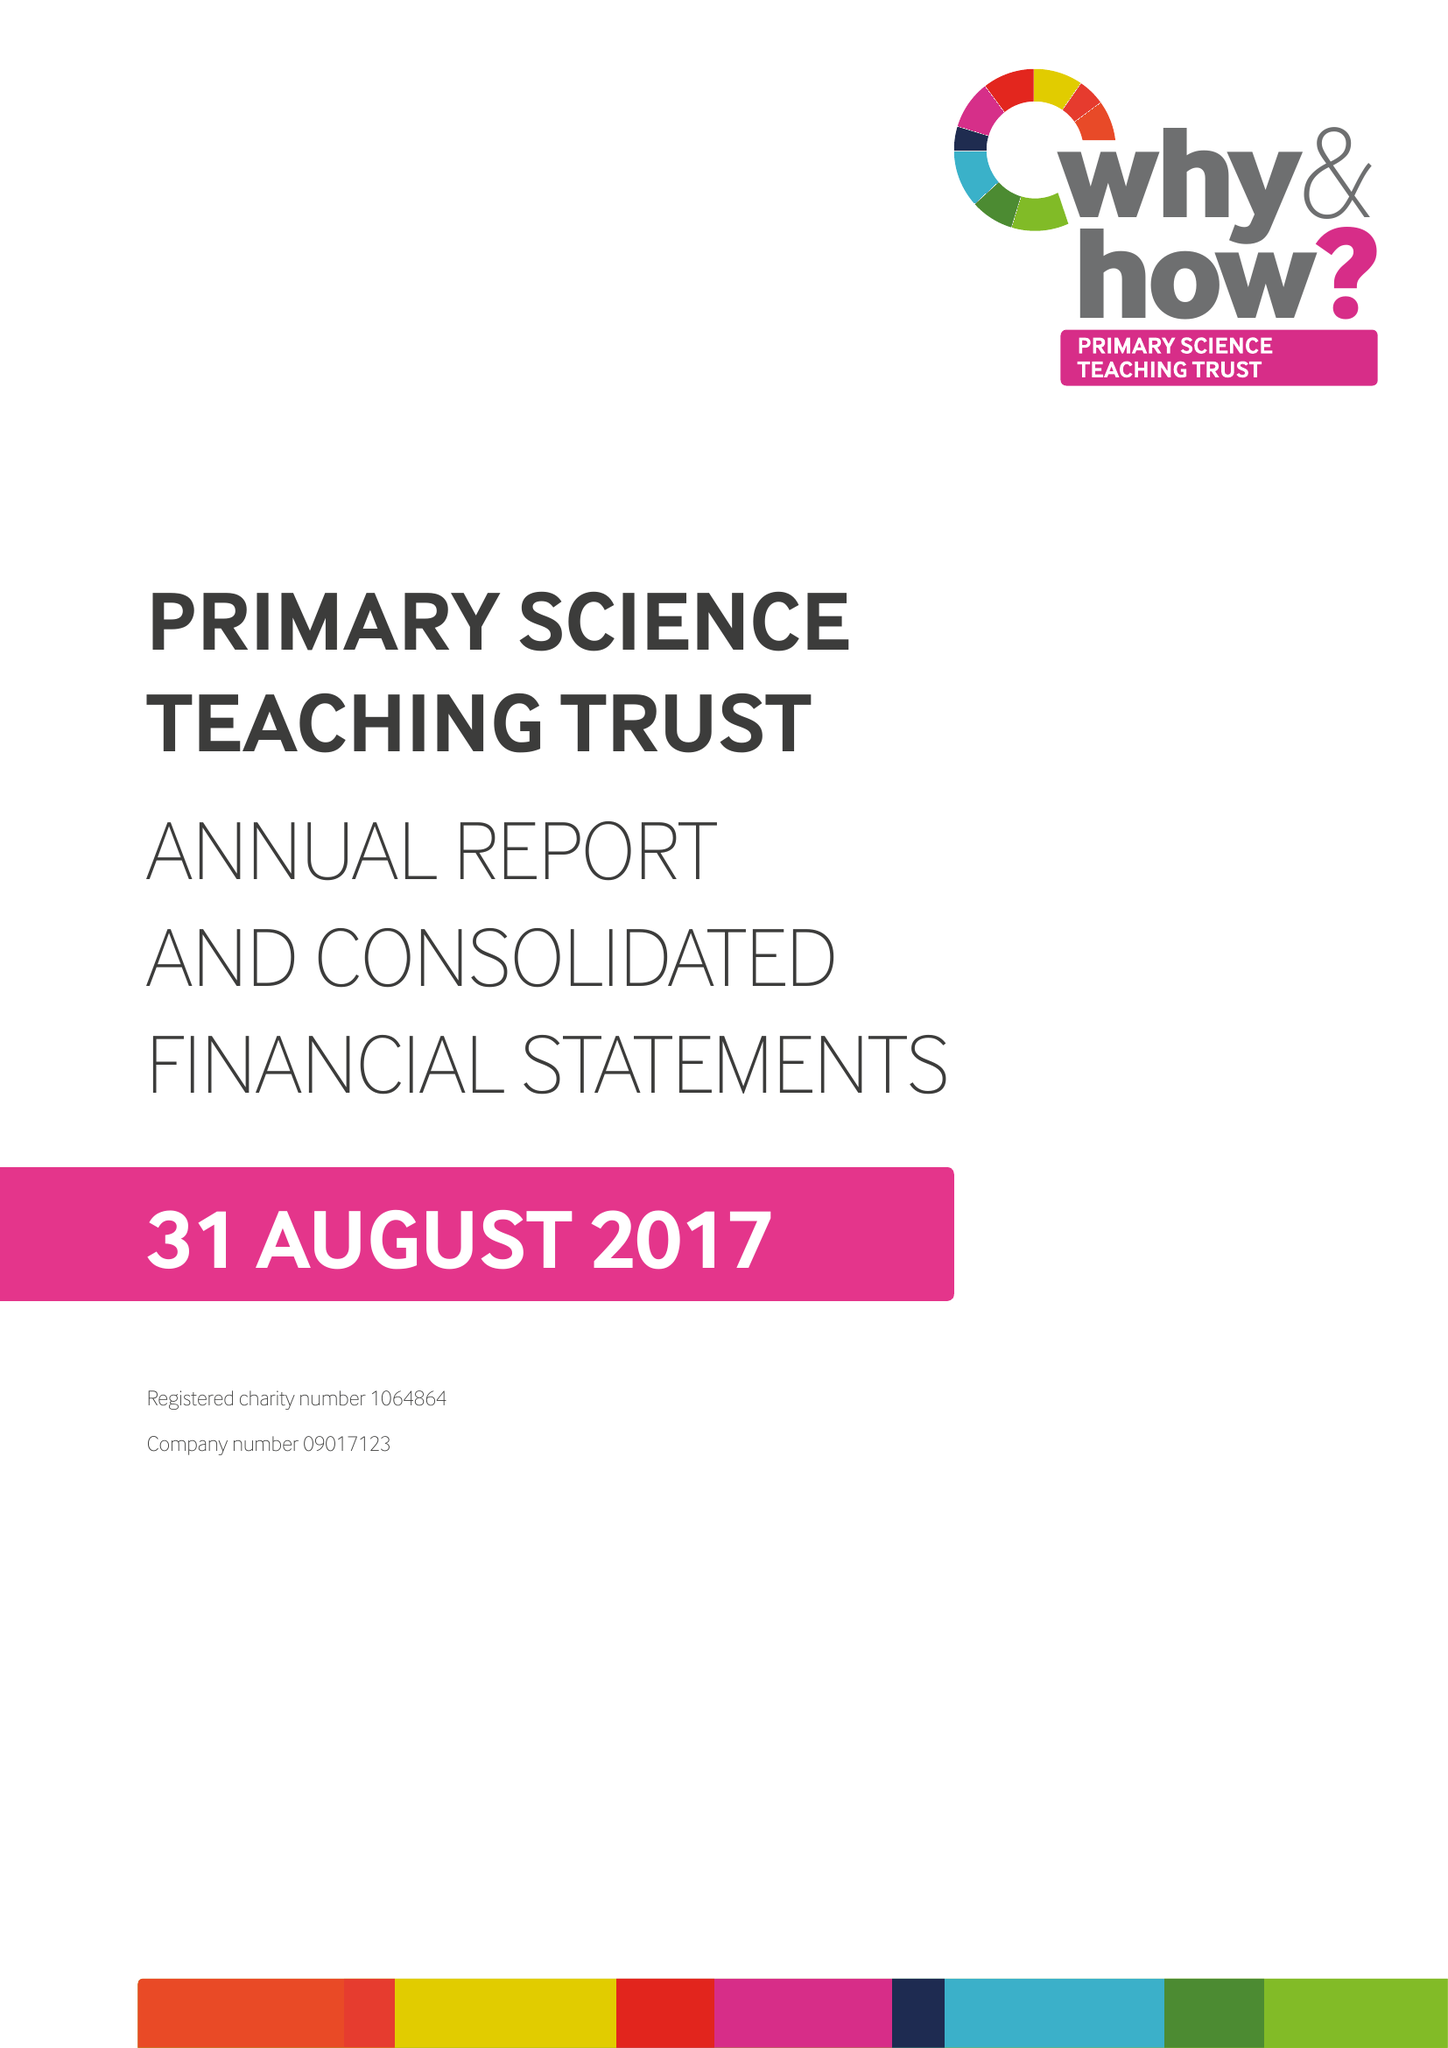What is the value for the address__postcode?
Answer the question using a single word or phrase. BS8 1PD 